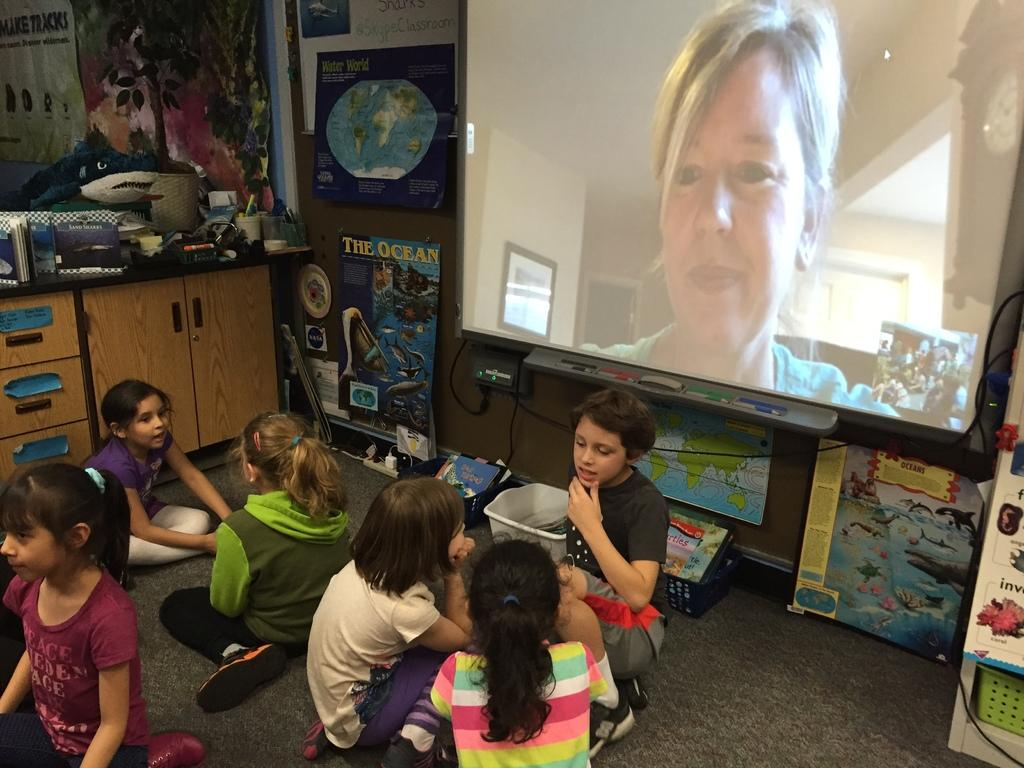What are the kids in the image doing? The kids are sitting on the floor in the image. What can be seen in the right corner of the image? There is a projected image in the right corner of the image. What else is visible in the background of the image? There are other objects visible in the background of the image. Are the kids playing chess in the image? There is no indication in the image that the kids are playing chess. 